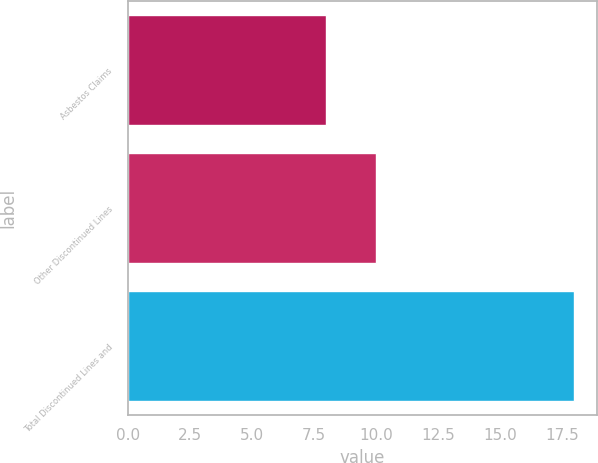Convert chart to OTSL. <chart><loc_0><loc_0><loc_500><loc_500><bar_chart><fcel>Asbestos Claims<fcel>Other Discontinued Lines<fcel>Total Discontinued Lines and<nl><fcel>8<fcel>10<fcel>18<nl></chart> 